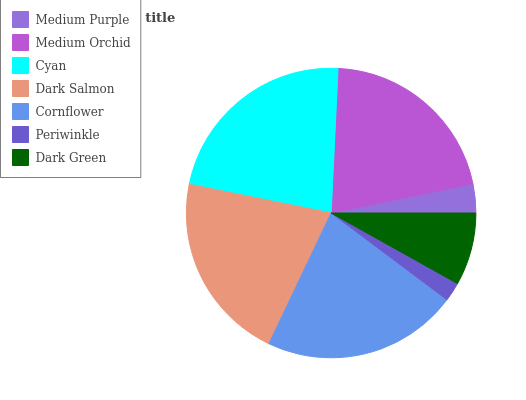Is Periwinkle the minimum?
Answer yes or no. Yes. Is Cyan the maximum?
Answer yes or no. Yes. Is Medium Orchid the minimum?
Answer yes or no. No. Is Medium Orchid the maximum?
Answer yes or no. No. Is Medium Orchid greater than Medium Purple?
Answer yes or no. Yes. Is Medium Purple less than Medium Orchid?
Answer yes or no. Yes. Is Medium Purple greater than Medium Orchid?
Answer yes or no. No. Is Medium Orchid less than Medium Purple?
Answer yes or no. No. Is Medium Orchid the high median?
Answer yes or no. Yes. Is Medium Orchid the low median?
Answer yes or no. Yes. Is Cyan the high median?
Answer yes or no. No. Is Dark Green the low median?
Answer yes or no. No. 